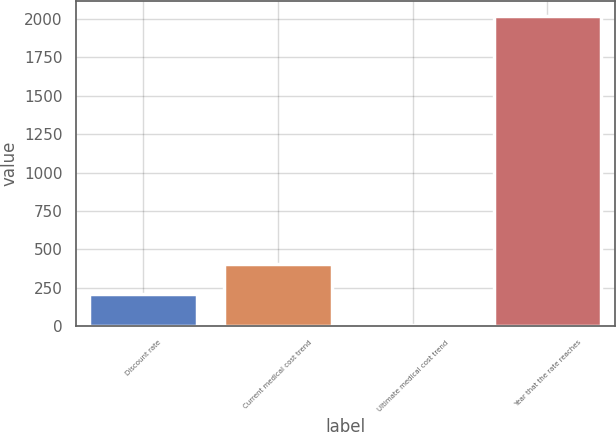Convert chart to OTSL. <chart><loc_0><loc_0><loc_500><loc_500><bar_chart><fcel>Discount rate<fcel>Current medical cost trend<fcel>Ultimate medical cost trend<fcel>Year that the rate reaches<nl><fcel>206.2<fcel>407.4<fcel>5<fcel>2017<nl></chart> 